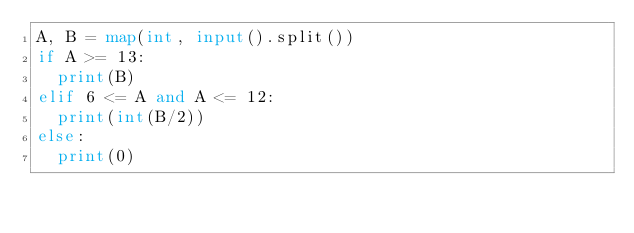<code> <loc_0><loc_0><loc_500><loc_500><_Python_>A, B = map(int, input().split())
if A >= 13:
  print(B)
elif 6 <= A and A <= 12:
  print(int(B/2))
else:
  print(0)</code> 